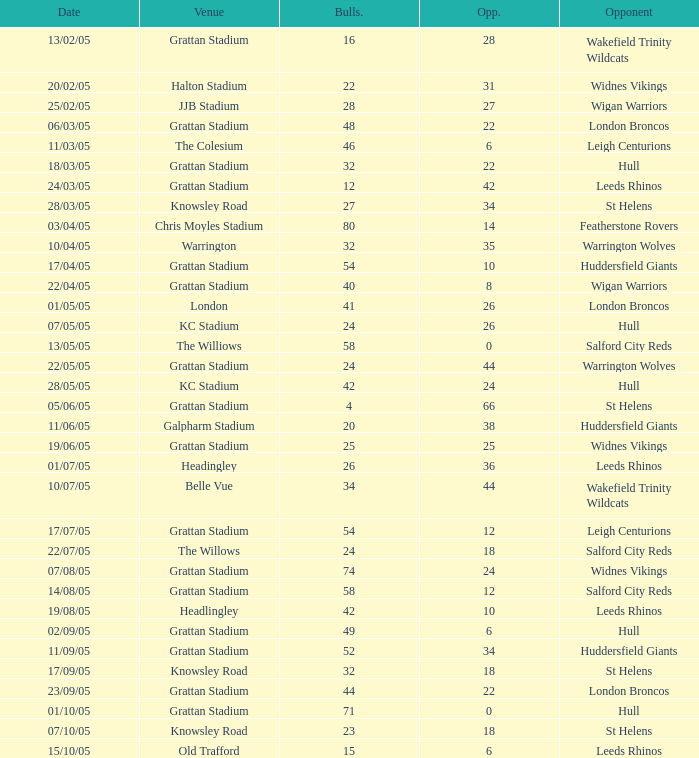What was the total number for the Bulls when they were at Old Trafford? 1.0. 